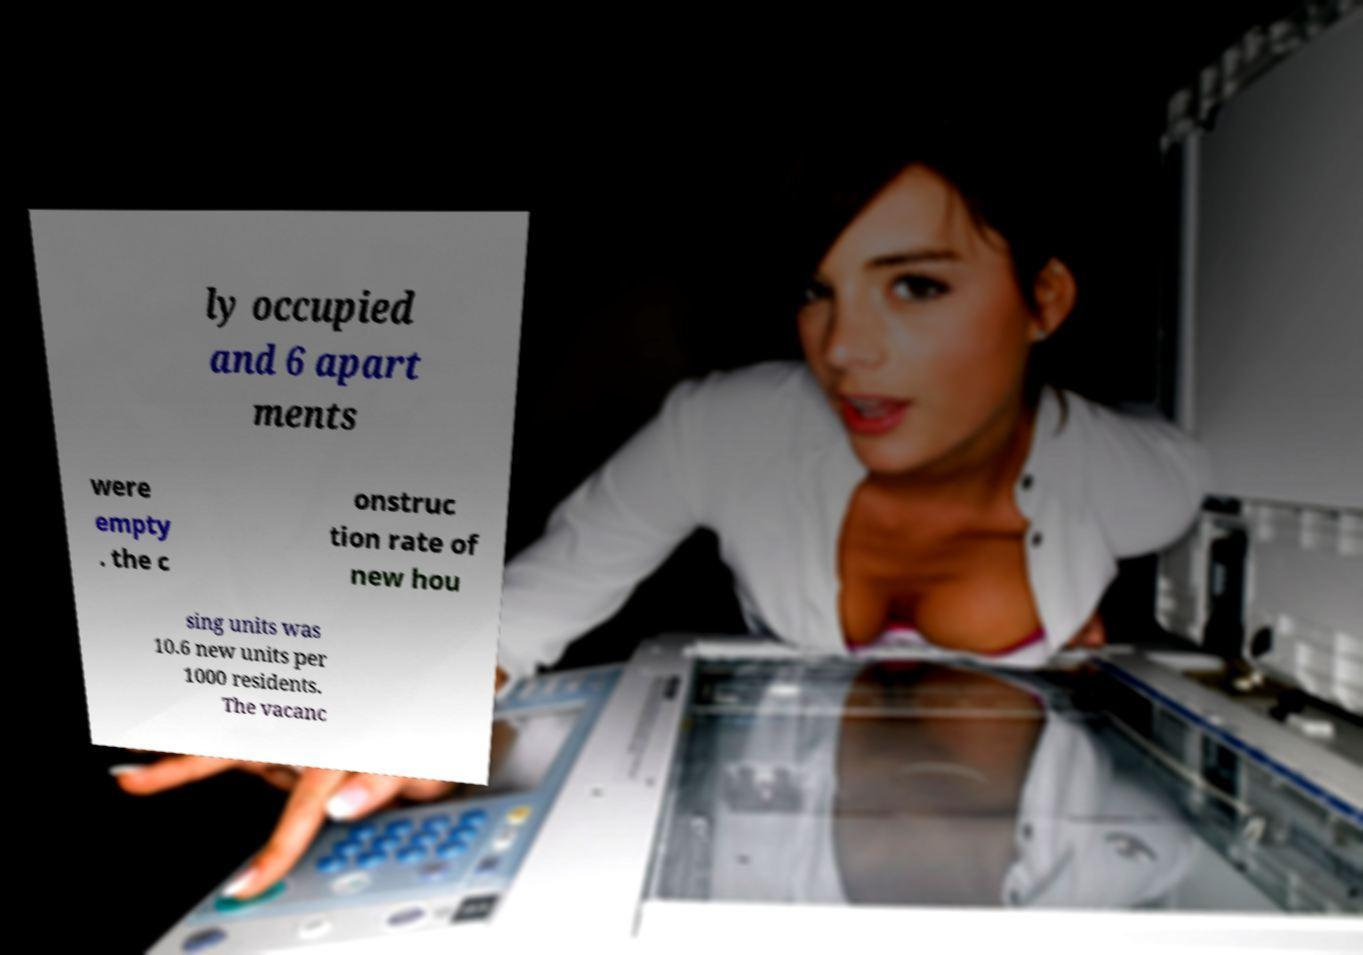Could you extract and type out the text from this image? ly occupied and 6 apart ments were empty . the c onstruc tion rate of new hou sing units was 10.6 new units per 1000 residents. The vacanc 